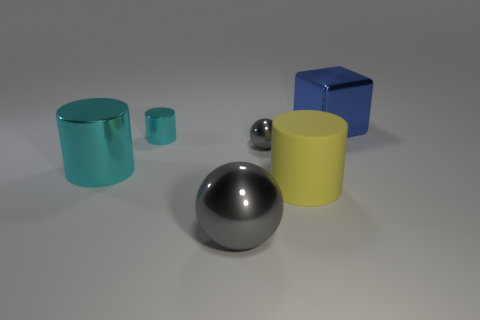Add 2 purple shiny blocks. How many objects exist? 8 Subtract all blocks. How many objects are left? 5 Subtract 0 green cubes. How many objects are left? 6 Subtract all blocks. Subtract all large spheres. How many objects are left? 4 Add 1 shiny cylinders. How many shiny cylinders are left? 3 Add 2 purple cubes. How many purple cubes exist? 2 